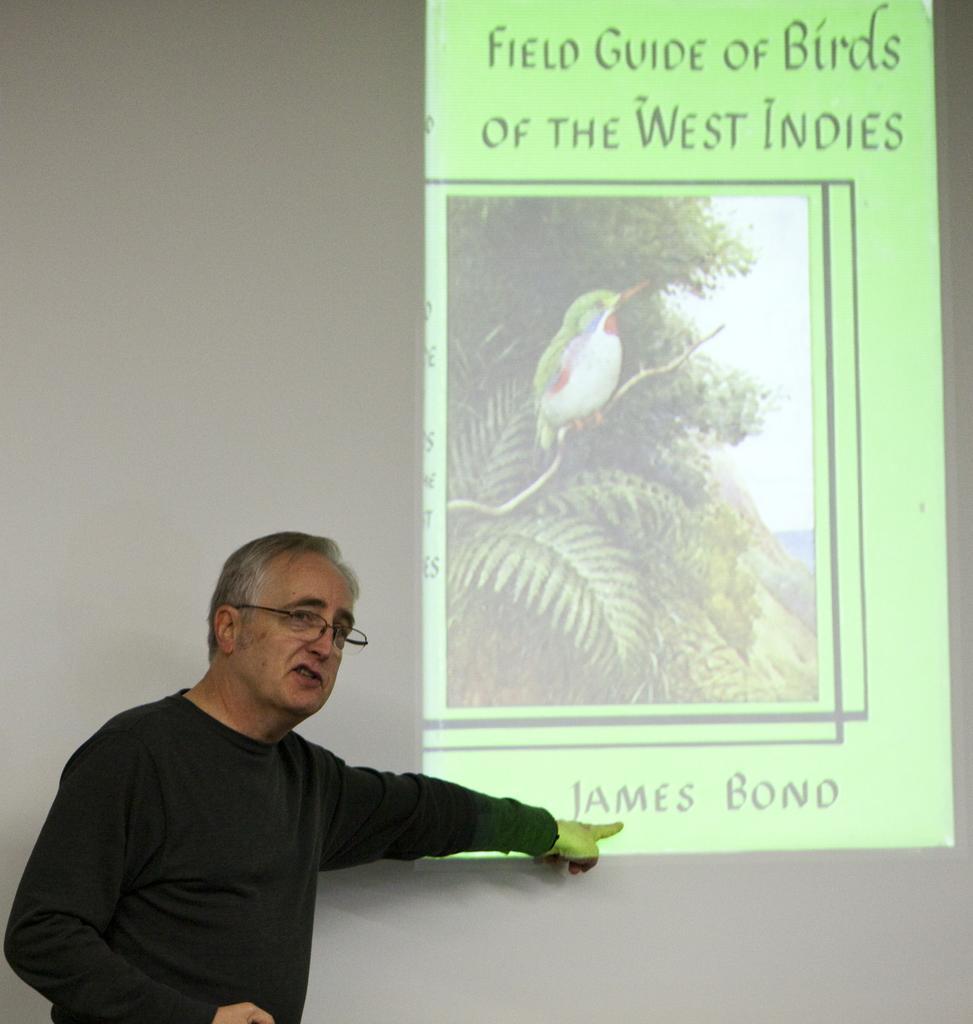Describe this image in one or two sentences. In this image we can see a person standing and wearing spectacles, on the wall we can see a screen with some images and text. 